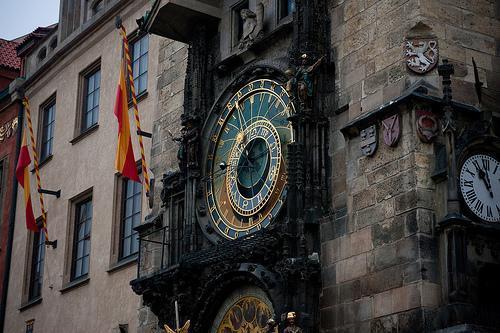How many flags are on the building?
Give a very brief answer. 2. How many clocks are there?
Give a very brief answer. 2. 